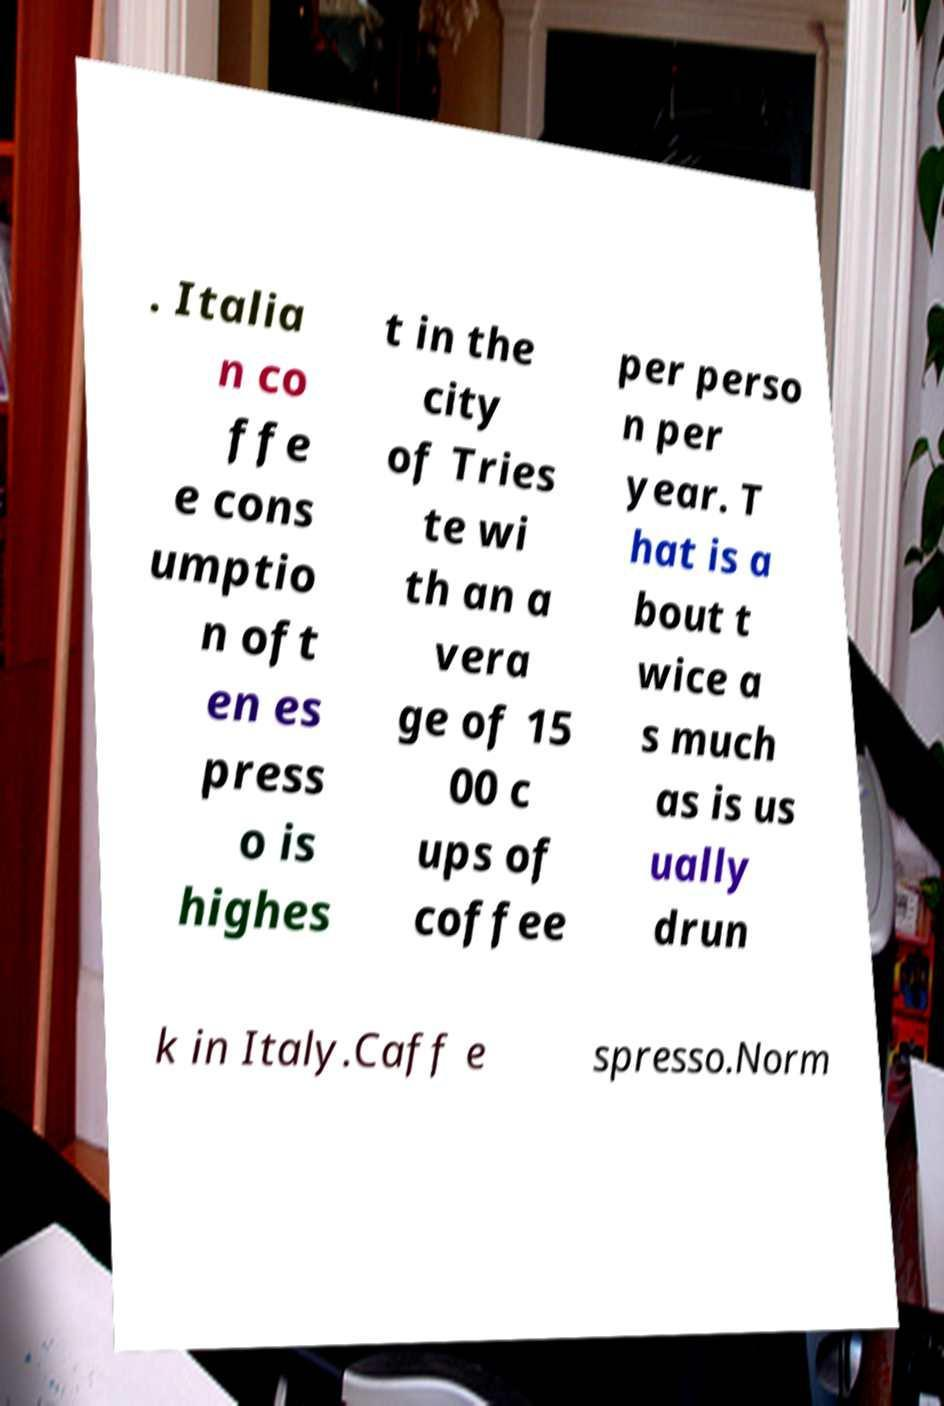Can you read and provide the text displayed in the image?This photo seems to have some interesting text. Can you extract and type it out for me? . Italia n co ffe e cons umptio n oft en es press o is highes t in the city of Tries te wi th an a vera ge of 15 00 c ups of coffee per perso n per year. T hat is a bout t wice a s much as is us ually drun k in Italy.Caff e spresso.Norm 